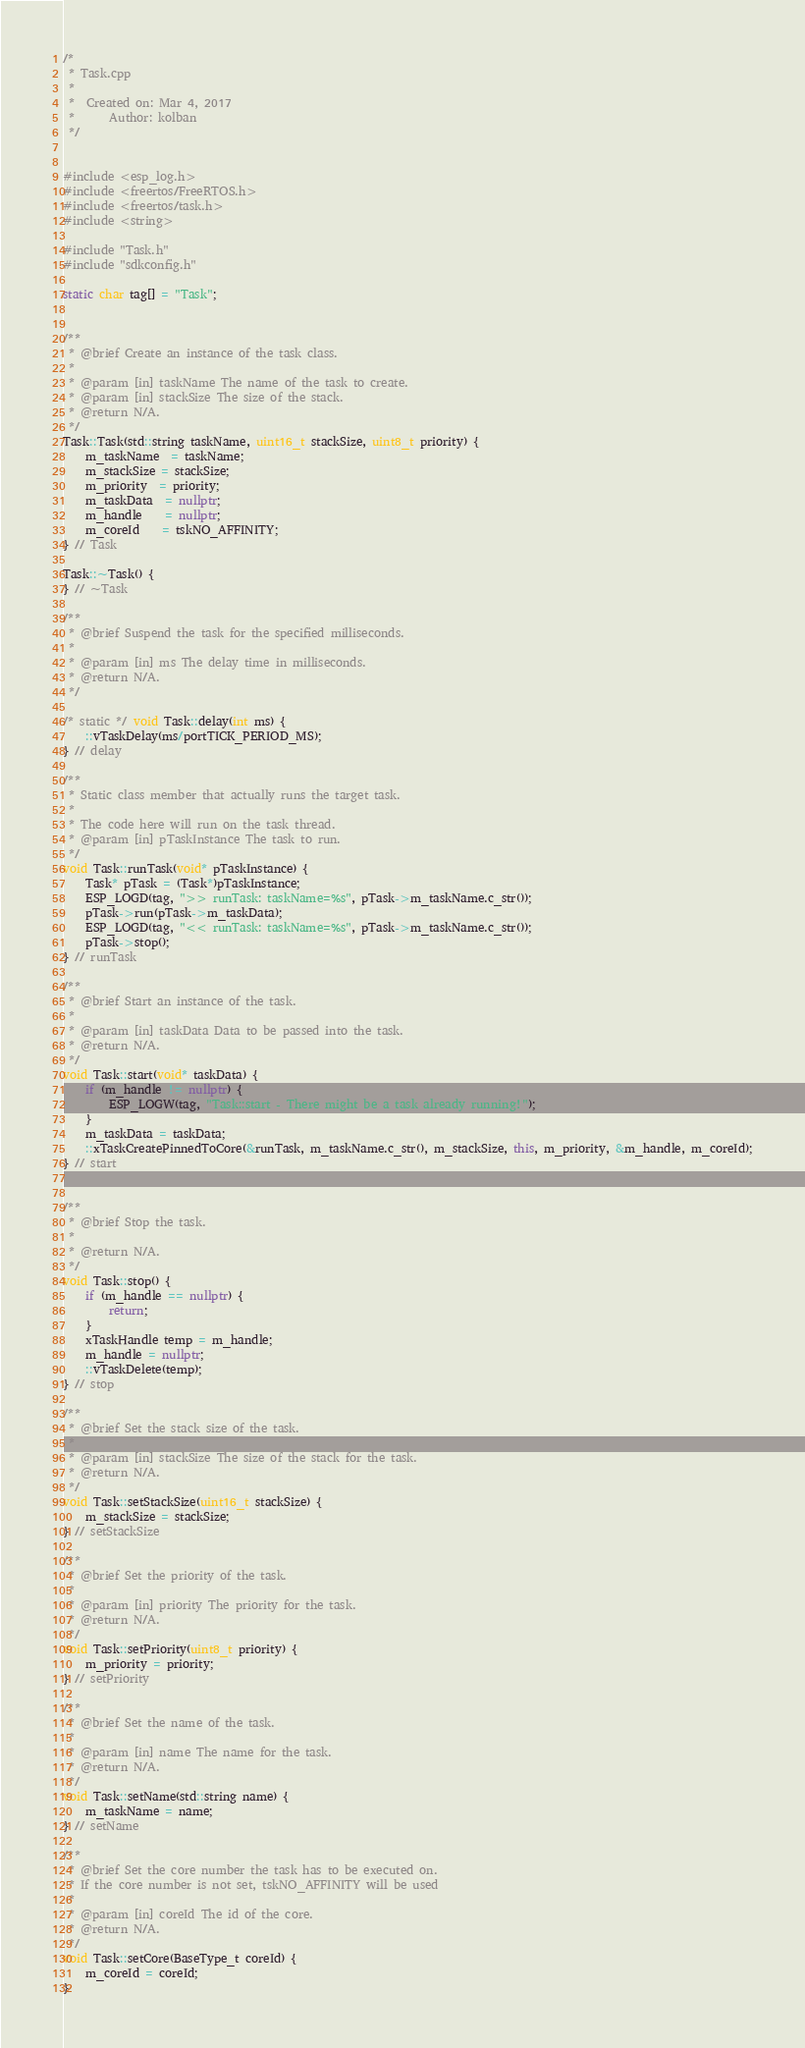Convert code to text. <code><loc_0><loc_0><loc_500><loc_500><_C++_>/*
 * Task.cpp
 *
 *  Created on: Mar 4, 2017
 *      Author: kolban
 */


#include <esp_log.h>
#include <freertos/FreeRTOS.h>
#include <freertos/task.h>
#include <string>

#include "Task.h"
#include "sdkconfig.h"

static char tag[] = "Task";


/**
 * @brief Create an instance of the task class.
 *
 * @param [in] taskName The name of the task to create.
 * @param [in] stackSize The size of the stack.
 * @return N/A.
 */
Task::Task(std::string taskName, uint16_t stackSize, uint8_t priority) {
	m_taskName  = taskName;
	m_stackSize = stackSize;
	m_priority  = priority;
	m_taskData  = nullptr;
	m_handle    = nullptr;
	m_coreId	= tskNO_AFFINITY;
} // Task

Task::~Task() {
} // ~Task

/**
 * @brief Suspend the task for the specified milliseconds.
 *
 * @param [in] ms The delay time in milliseconds.
 * @return N/A.
 */

/* static */ void Task::delay(int ms) {
	::vTaskDelay(ms/portTICK_PERIOD_MS);
} // delay

/**
 * Static class member that actually runs the target task.
 *
 * The code here will run on the task thread.
 * @param [in] pTaskInstance The task to run.
 */
void Task::runTask(void* pTaskInstance) {
	Task* pTask = (Task*)pTaskInstance;
	ESP_LOGD(tag, ">> runTask: taskName=%s", pTask->m_taskName.c_str());
	pTask->run(pTask->m_taskData);
	ESP_LOGD(tag, "<< runTask: taskName=%s", pTask->m_taskName.c_str());
	pTask->stop();
} // runTask

/**
 * @brief Start an instance of the task.
 *
 * @param [in] taskData Data to be passed into the task.
 * @return N/A.
 */
void Task::start(void* taskData) {
	if (m_handle != nullptr) {
		ESP_LOGW(tag, "Task::start - There might be a task already running!");
	}
	m_taskData = taskData;
	::xTaskCreatePinnedToCore(&runTask, m_taskName.c_str(), m_stackSize, this, m_priority, &m_handle, m_coreId);
} // start


/**
 * @brief Stop the task.
 *
 * @return N/A.
 */
void Task::stop() {
	if (m_handle == nullptr) {
		return;
	}
	xTaskHandle temp = m_handle;
	m_handle = nullptr;
	::vTaskDelete(temp);
} // stop

/**
 * @brief Set the stack size of the task.
 *
 * @param [in] stackSize The size of the stack for the task.
 * @return N/A.
 */
void Task::setStackSize(uint16_t stackSize) {
	m_stackSize = stackSize;
} // setStackSize

/**
 * @brief Set the priority of the task.
 *
 * @param [in] priority The priority for the task.
 * @return N/A.
 */
void Task::setPriority(uint8_t priority) {
	m_priority = priority;
} // setPriority

/**
 * @brief Set the name of the task.
 *
 * @param [in] name The name for the task.
 * @return N/A.
 */
void Task::setName(std::string name) {
	m_taskName = name;
} // setName

/**
 * @brief Set the core number the task has to be executed on.
 * If the core number is not set, tskNO_AFFINITY will be used
 *
 * @param [in] coreId The id of the core.
 * @return N/A.
 */
void Task::setCore(BaseType_t coreId) {
	m_coreId = coreId;
}
</code> 